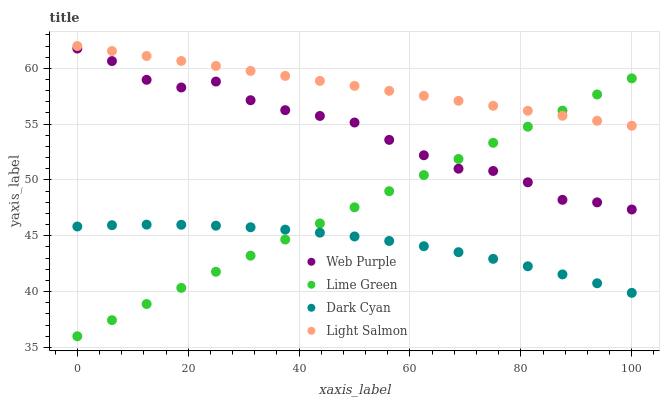Does Dark Cyan have the minimum area under the curve?
Answer yes or no. Yes. Does Light Salmon have the maximum area under the curve?
Answer yes or no. Yes. Does Web Purple have the minimum area under the curve?
Answer yes or no. No. Does Web Purple have the maximum area under the curve?
Answer yes or no. No. Is Light Salmon the smoothest?
Answer yes or no. Yes. Is Web Purple the roughest?
Answer yes or no. Yes. Is Lime Green the smoothest?
Answer yes or no. No. Is Lime Green the roughest?
Answer yes or no. No. Does Lime Green have the lowest value?
Answer yes or no. Yes. Does Web Purple have the lowest value?
Answer yes or no. No. Does Light Salmon have the highest value?
Answer yes or no. Yes. Does Web Purple have the highest value?
Answer yes or no. No. Is Web Purple less than Light Salmon?
Answer yes or no. Yes. Is Web Purple greater than Dark Cyan?
Answer yes or no. Yes. Does Light Salmon intersect Lime Green?
Answer yes or no. Yes. Is Light Salmon less than Lime Green?
Answer yes or no. No. Is Light Salmon greater than Lime Green?
Answer yes or no. No. Does Web Purple intersect Light Salmon?
Answer yes or no. No. 